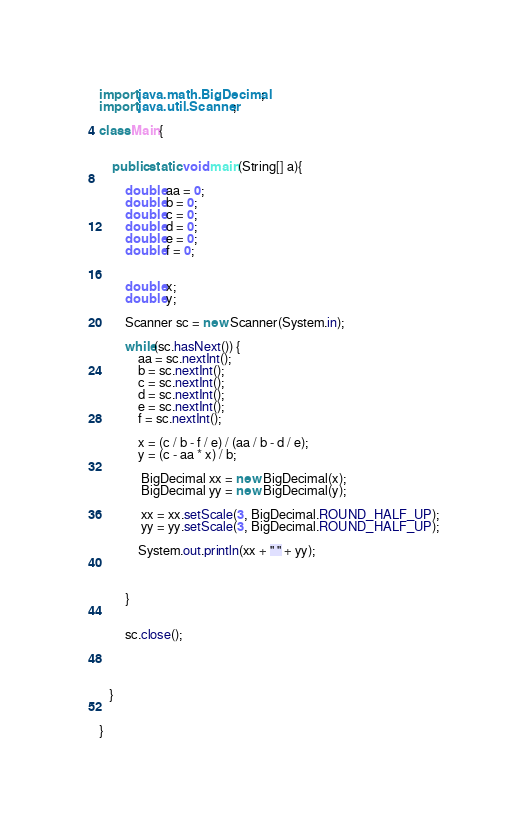<code> <loc_0><loc_0><loc_500><loc_500><_Java_>import java.math.BigDecimal;
import java.util.Scanner;

class Main{


    public static void main(String[] a){

    	double aa = 0;
    	double b = 0;
    	double c = 0;
    	double d = 0;
    	double e = 0;
    	double f = 0;


    	double x;
    	double y;

    	Scanner sc = new Scanner(System.in);

        while(sc.hasNext()) {
        	aa = sc.nextInt();
        	b = sc.nextInt();
        	c = sc.nextInt();
        	d = sc.nextInt();
        	e = sc.nextInt();
        	f = sc.nextInt();

         	x = (c / b - f / e) / (aa / b - d / e);
    		y = (c - aa * x) / b;

    		 BigDecimal xx = new BigDecimal(x);
    		 BigDecimal yy = new BigDecimal(y);

    		 xx = xx.setScale(3, BigDecimal.ROUND_HALF_UP);
    		 yy = yy.setScale(3, BigDecimal.ROUND_HALF_UP);

        	System.out.println(xx + " " + yy);



        }


        sc.close();




   }


}</code> 